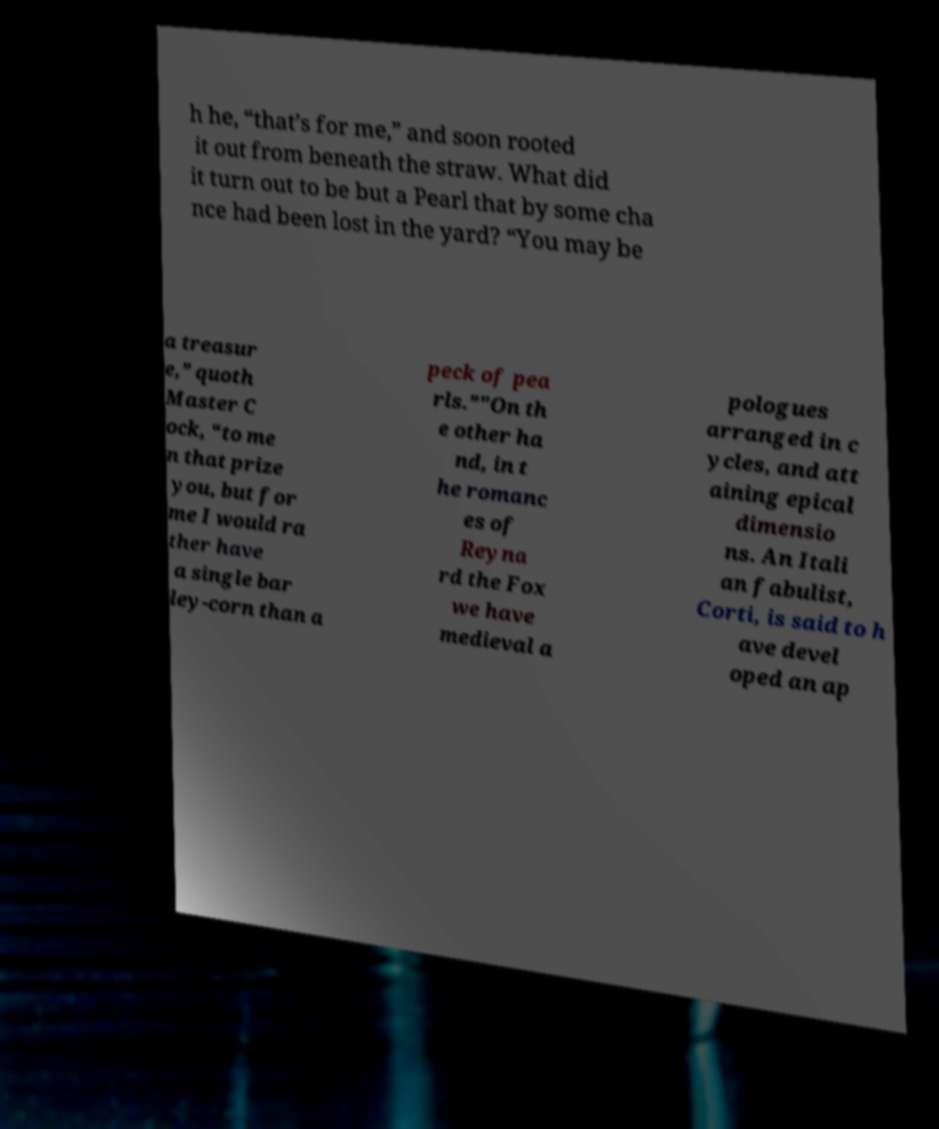Can you read and provide the text displayed in the image?This photo seems to have some interesting text. Can you extract and type it out for me? h he, “that’s for me,” and soon rooted it out from beneath the straw. What did it turn out to be but a Pearl that by some cha nce had been lost in the yard? “You may be a treasur e,” quoth Master C ock, “to me n that prize you, but for me I would ra ther have a single bar ley-corn than a peck of pea rls.”"On th e other ha nd, in t he romanc es of Reyna rd the Fox we have medieval a pologues arranged in c ycles, and att aining epical dimensio ns. An Itali an fabulist, Corti, is said to h ave devel oped an ap 